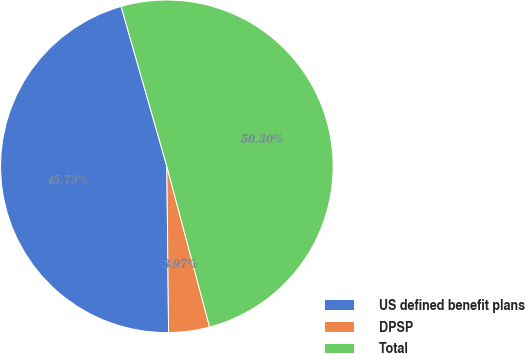<chart> <loc_0><loc_0><loc_500><loc_500><pie_chart><fcel>US defined benefit plans<fcel>DPSP<fcel>Total<nl><fcel>45.73%<fcel>3.97%<fcel>50.3%<nl></chart> 